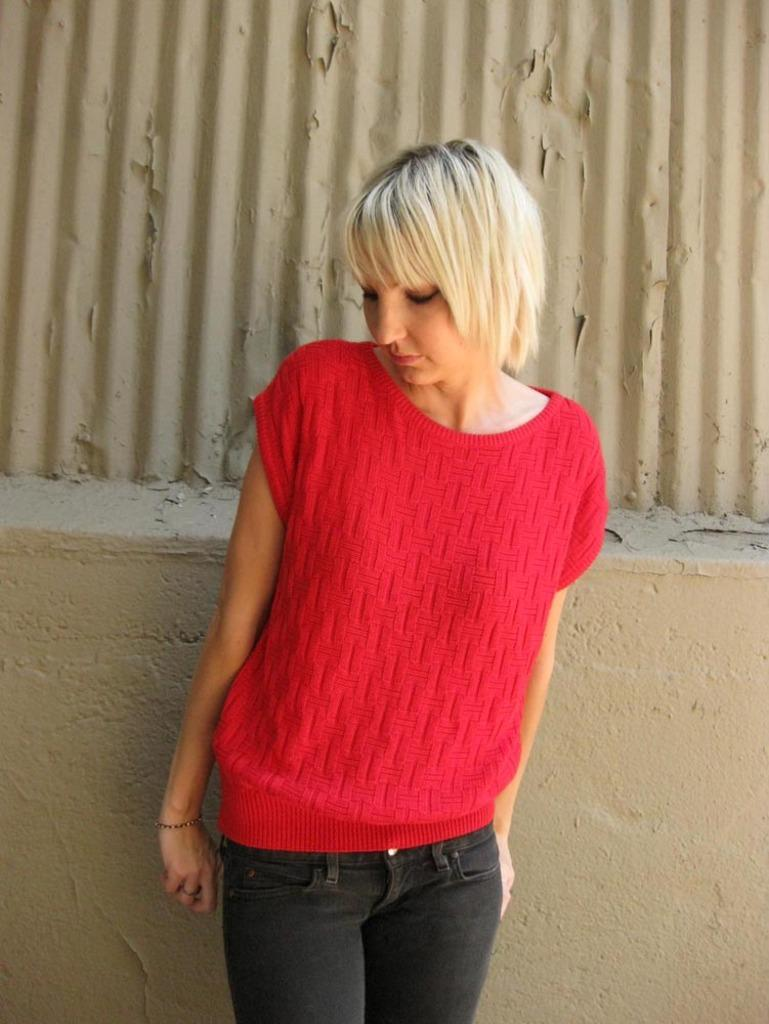Who or what is present in the image? There is a person in the image. What is the person wearing? The person is wearing clothes. What can be seen in the background of the image? There is a wall in the background of the image. How many frogs are sitting on the person's shoulder in the image? There are no frogs present in the image. Is the person in the image a police officer? The image does not provide any information about the person's occupation, so it cannot be determined if they are a police officer. 